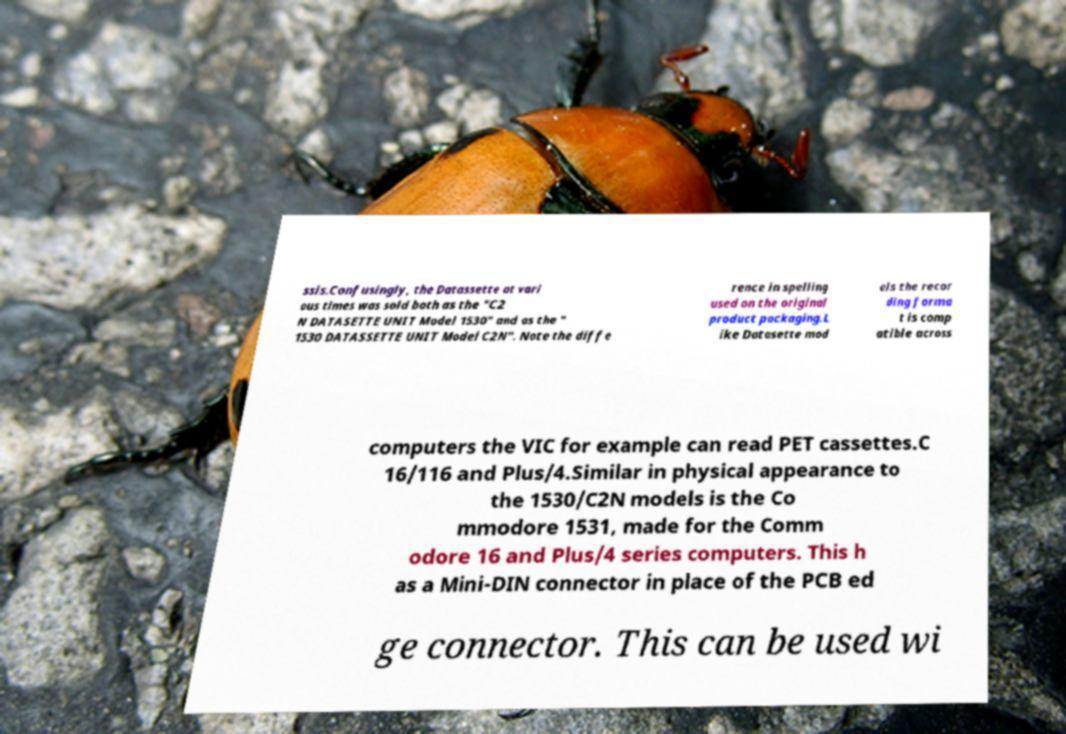Could you extract and type out the text from this image? ssis.Confusingly, the Datassette at vari ous times was sold both as the "C2 N DATASETTE UNIT Model 1530" and as the " 1530 DATASSETTE UNIT Model C2N". Note the diffe rence in spelling used on the original product packaging.L ike Datasette mod els the recor ding forma t is comp atible across computers the VIC for example can read PET cassettes.C 16/116 and Plus/4.Similar in physical appearance to the 1530/C2N models is the Co mmodore 1531, made for the Comm odore 16 and Plus/4 series computers. This h as a Mini-DIN connector in place of the PCB ed ge connector. This can be used wi 